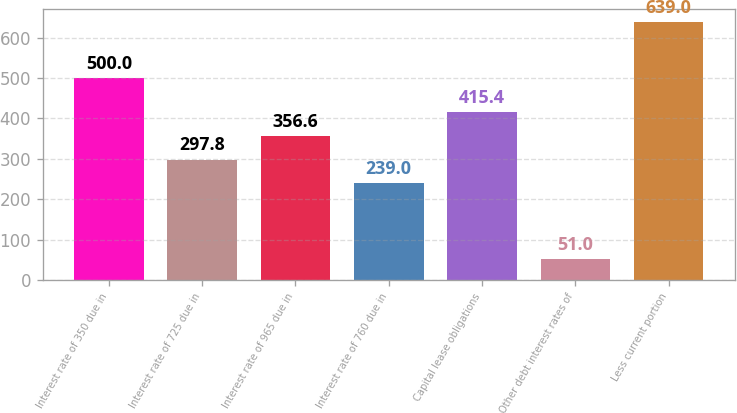Convert chart to OTSL. <chart><loc_0><loc_0><loc_500><loc_500><bar_chart><fcel>Interest rate of 350 due in<fcel>Interest rate of 725 due in<fcel>Interest rate of 965 due in<fcel>Interest rate of 760 due in<fcel>Capital lease obligations<fcel>Other debt interest rates of<fcel>Less current portion<nl><fcel>500<fcel>297.8<fcel>356.6<fcel>239<fcel>415.4<fcel>51<fcel>639<nl></chart> 